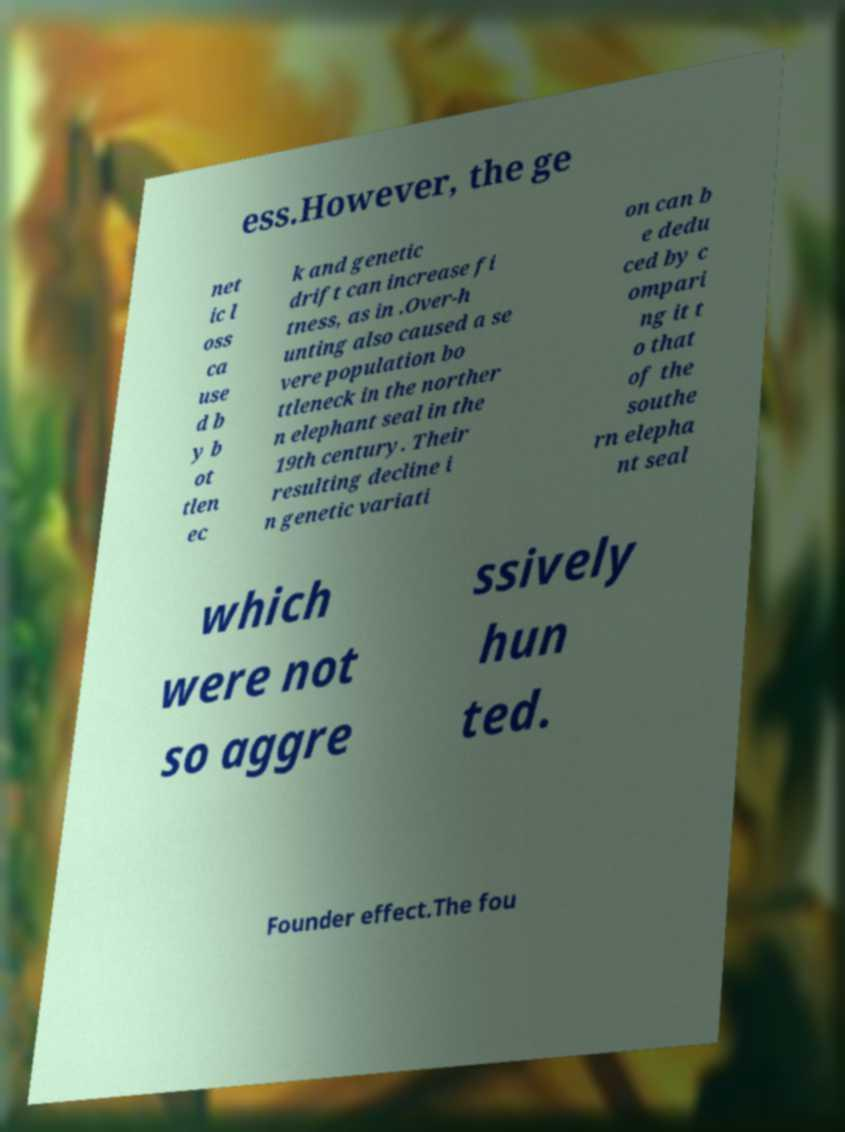Please read and relay the text visible in this image. What does it say? ess.However, the ge net ic l oss ca use d b y b ot tlen ec k and genetic drift can increase fi tness, as in .Over-h unting also caused a se vere population bo ttleneck in the norther n elephant seal in the 19th century. Their resulting decline i n genetic variati on can b e dedu ced by c ompari ng it t o that of the southe rn elepha nt seal which were not so aggre ssively hun ted. Founder effect.The fou 